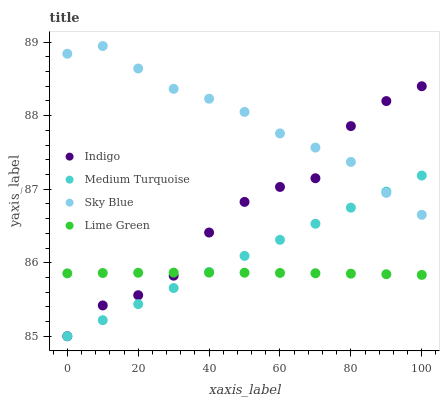Does Lime Green have the minimum area under the curve?
Answer yes or no. Yes. Does Sky Blue have the maximum area under the curve?
Answer yes or no. Yes. Does Indigo have the minimum area under the curve?
Answer yes or no. No. Does Indigo have the maximum area under the curve?
Answer yes or no. No. Is Medium Turquoise the smoothest?
Answer yes or no. Yes. Is Indigo the roughest?
Answer yes or no. Yes. Is Sky Blue the smoothest?
Answer yes or no. No. Is Sky Blue the roughest?
Answer yes or no. No. Does Indigo have the lowest value?
Answer yes or no. Yes. Does Sky Blue have the lowest value?
Answer yes or no. No. Does Sky Blue have the highest value?
Answer yes or no. Yes. Does Indigo have the highest value?
Answer yes or no. No. Is Lime Green less than Sky Blue?
Answer yes or no. Yes. Is Sky Blue greater than Lime Green?
Answer yes or no. Yes. Does Lime Green intersect Medium Turquoise?
Answer yes or no. Yes. Is Lime Green less than Medium Turquoise?
Answer yes or no. No. Is Lime Green greater than Medium Turquoise?
Answer yes or no. No. Does Lime Green intersect Sky Blue?
Answer yes or no. No. 